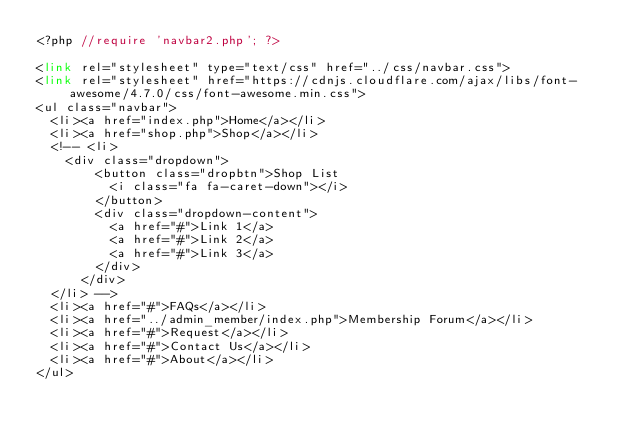<code> <loc_0><loc_0><loc_500><loc_500><_PHP_><?php //require 'navbar2.php'; ?>

<link rel="stylesheet" type="text/css" href="../css/navbar.css">
<link rel="stylesheet" href="https://cdnjs.cloudflare.com/ajax/libs/font-awesome/4.7.0/css/font-awesome.min.css">
<ul class="navbar">
	<li><a href="index.php">Home</a></li>
	<li><a href="shop.php">Shop</a></li>
	<!-- <li>
		<div class="dropdown">
		    <button class="dropbtn">Shop List
		      <i class="fa fa-caret-down"></i>
		    </button>
		    <div class="dropdown-content">
		      <a href="#">Link 1</a>
		      <a href="#">Link 2</a>
		      <a href="#">Link 3</a>
		    </div>
	  	</div>
	</li> -->
	<li><a href="#">FAQs</a></li>
	<li><a href="../admin_member/index.php">Membership Forum</a></li>
	<li><a href="#">Request</a></li>
	<li><a href="#">Contact Us</a></li>
	<li><a href="#">About</a></li>
</ul></code> 